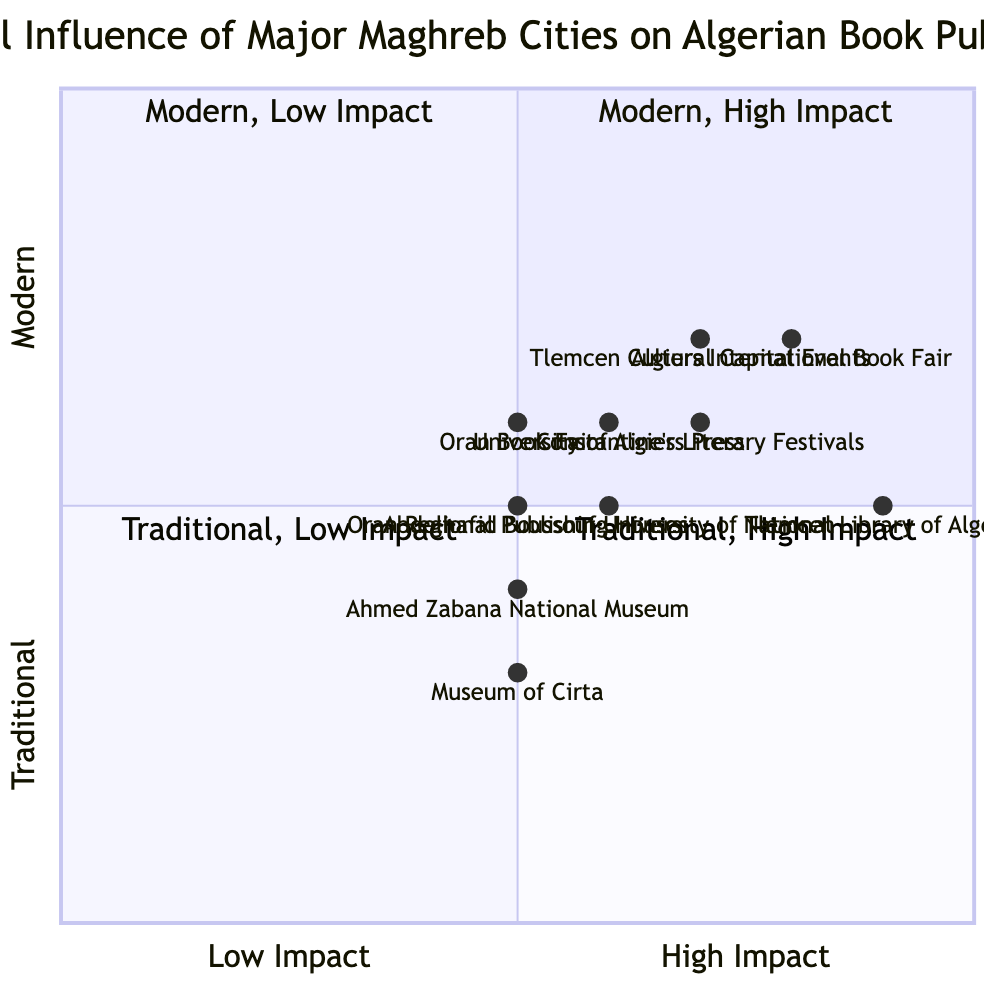What is the impact level of the National Library of Algeria? The National Library of Algeria is categorized under High impact in the diagram.
Answer: High Which city has the Algiers International Book Fair? The Algiers International Book Fair is located in Algiers, as indicated in the quadrant.
Answer: Algiers How many elements are in the Oran quadrant? There are three elements listed in the Oran quadrant: Ahmed Zabana National Museum, Oran Book Fair, and Oran Regional Publishing Houses.
Answer: 3 What is the impact rating for Constantine's Literary Festivals? The impact rating for Constantine's Literary Festivals is High, according to the quadrant chart.
Answer: High Which entity in Tlemcen has a Medium impact rating? The Abdelhafid Boussouf University of Tlemcen is noted for having a Medium impact rating in the Tlemcen quadrant.
Answer: Abdelhafid Boussouf University of Tlemcen Which quadrant features elements with a High impact and modern characteristics? Algiers and Tlemcen contain elements with High impact rated as modern, based on their positioning in Quadrant 1.
Answer: Algiers, Tlemcen What is the position of the Oran Regional Publishing Houses in the quadrant? The Oran Regional Publishing Houses fall into the quadrant labeled for Traditional, Low Impact, located toward the lower left area of the chart.
Answer: Traditional, Low Impact What two cities feature cultural events promoting literature with High impact? Algiers and Tlemcen are both cities that have cultural events with High impact promoting literature.
Answer: Algiers, Tlemcen List the description of the University of Algiers Press. The University of Algiers Press is described as a major academic publisher influencing scholarly works on Algerian and Maghreb culture.
Answer: Major academic publisher influencing scholarly works on Algerian and Maghreb culture 